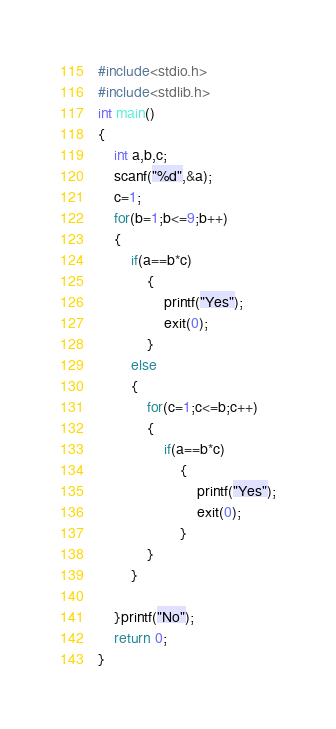Convert code to text. <code><loc_0><loc_0><loc_500><loc_500><_C_>#include<stdio.h>
#include<stdlib.h>
int main()
{
    int a,b,c;
    scanf("%d",&a);
    c=1;
    for(b=1;b<=9;b++)
    {
        if(a==b*c)
            {
                printf("Yes");
                exit(0);
            }
        else
        {
            for(c=1;c<=b;c++)
            {
                if(a==b*c)
                    {
                        printf("Yes");
                        exit(0);
                    }
            }
        }

    }printf("No");
    return 0;
}

</code> 